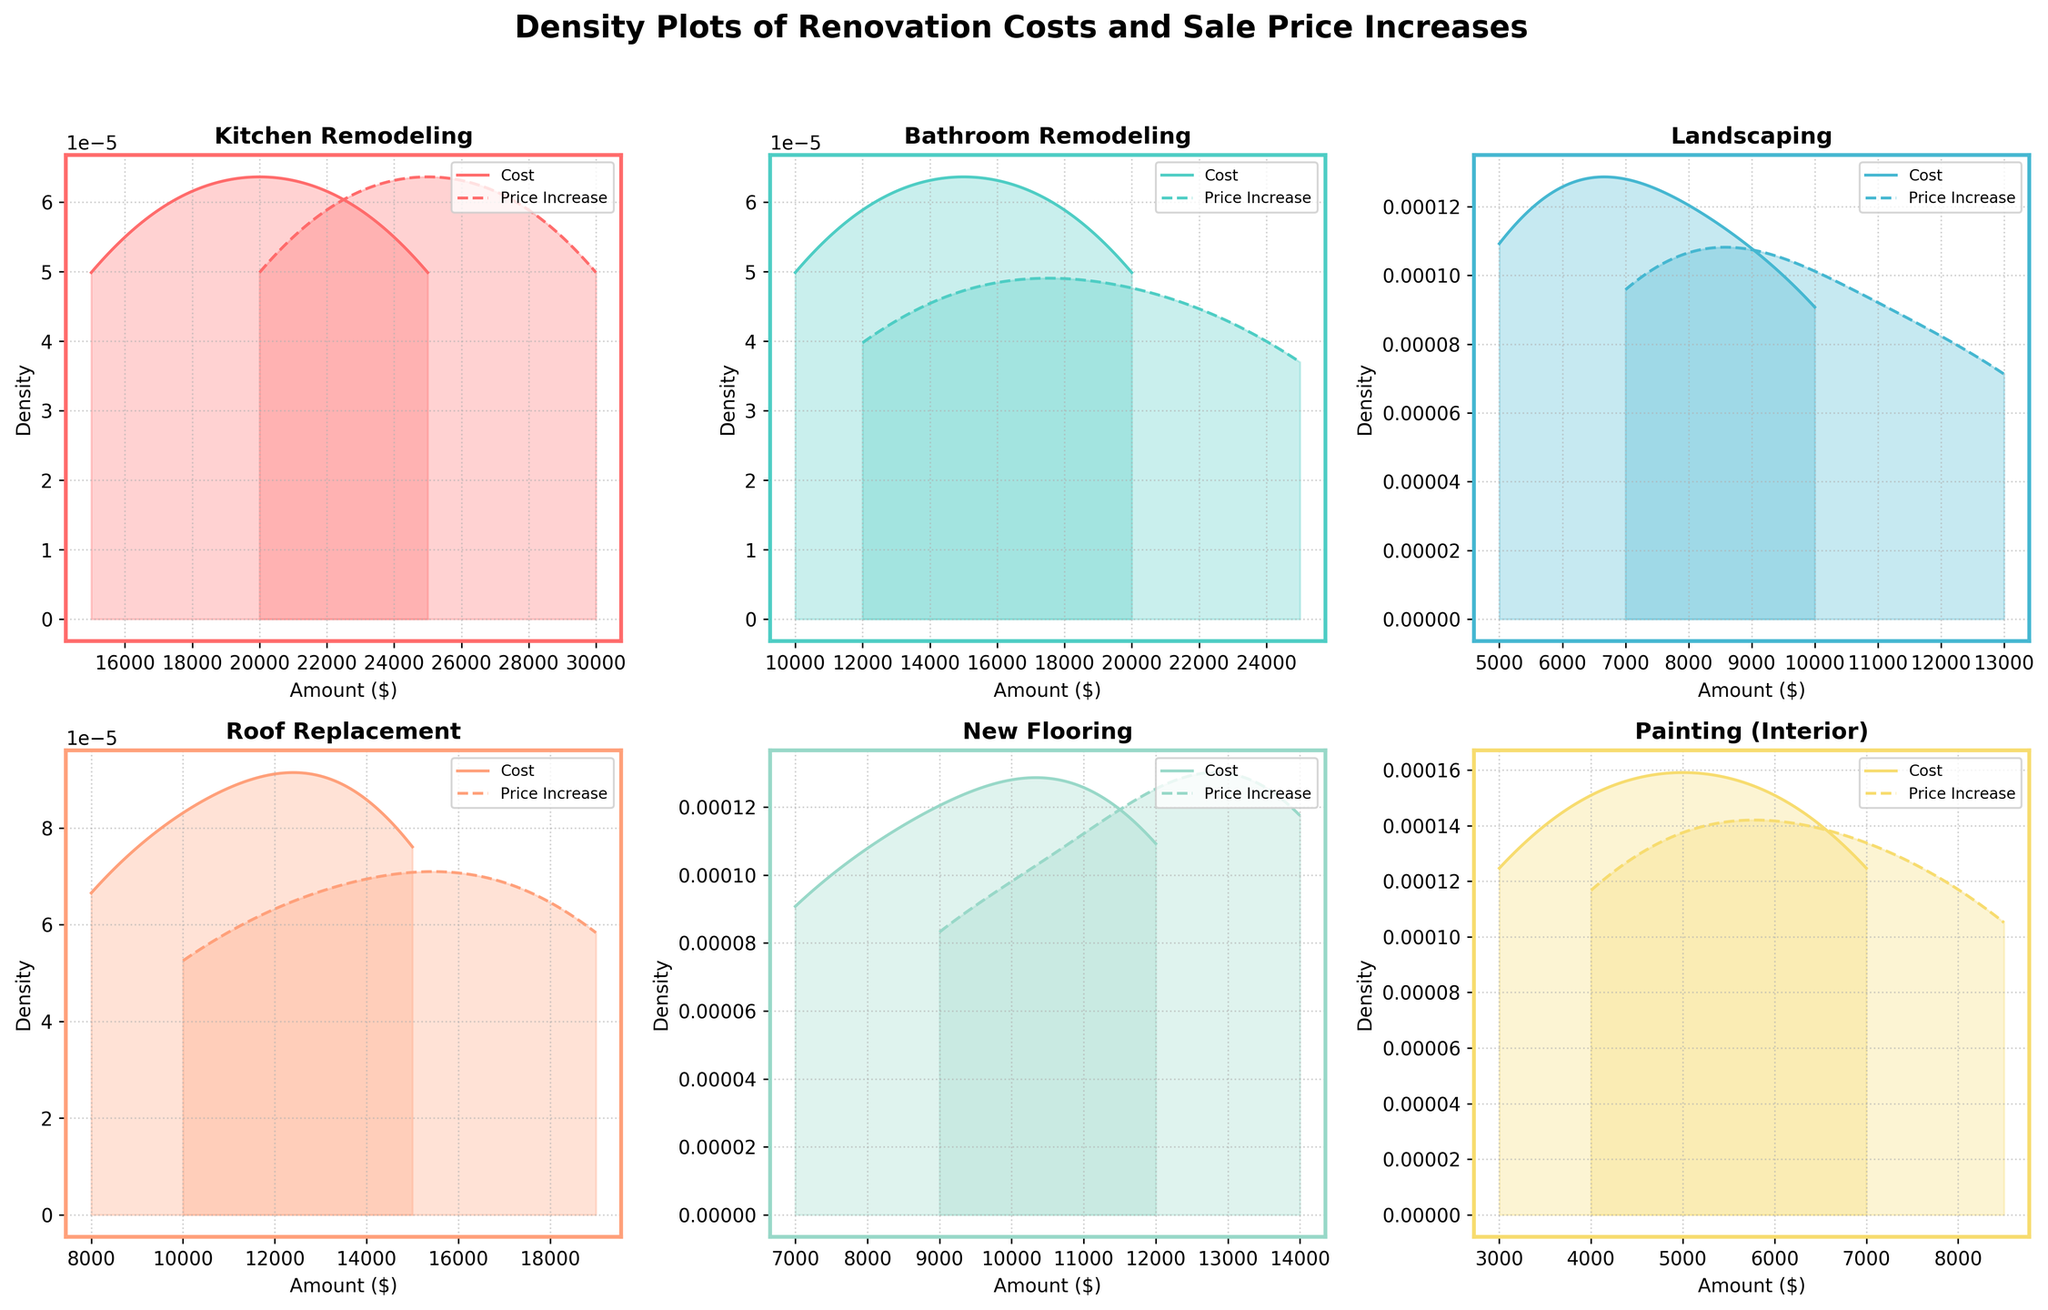how many renovation types are displayed in the plot? The figure has a separate density plot for each type of renovation, and the titles of each subplot show the renovation types. By counting the number of subplots, we can determine the number of renovation types. There are 6 types in total.
Answer: 6 what does the solid line represent in each subplot? Each subplot contains two lines, a solid and a dashed one. According to the labels in the legend, the solid line represents the estimated density of renovation costs.
Answer: Estimated density of renovation costs which renovation type has the highest density peak for cost? By comparing the peaks of the solid lines in each subplot, we see that 'Kitchen Remodeling' exhibits the highest peak in the estimated density for costs.
Answer: Kitchen Remodeling what is the x-axis label in each subplot? Each subplot has axes labeled, and the x-axis is titled 'Amount ($)', which represents the monetary value measured in dollars.
Answer: Amount ($) which renovation type has the smallest width of distribution for cost? Observing the width of the solid lines' spread along the x-axis in each subplot, 'Painting (Interior)' demonstrates the smallest width, indicating the smallest variation in renovation costs.
Answer: Painting (Interior) does roofing replacement display a higher peak density for cost or price increase? In the 'Roof Replacement' subplot, we compare the heights of the solid and dashed lines. The solid line (cost) shows a higher peak density than the dashed line (price increase).
Answer: Cost has higher peak density which renovation type has the highest density peak for price increase? By examining the peaks of the dashed lines in each subplot, 'Kitchen Remodeling' shows the highest density peak for the price increase, suggesting a significant increase in sale price.
Answer: Kitchen Remodeling are the densities for cost and price increase for new flooring closely aligned or spread apart? Looking at the 'New Flooring' subplot, the solid (cost) and dashed (price increase) lines are quite close to each other, indicating closely aligned densities.
Answer: Closely aligned which renovation type appears to be the most variable in terms of price increase? The variation can be assessed by looking at the spread of the dashed line in each subplot. 'Kitchen Remodeling' shows a wide spread in the dashed line, indicating high variability in price increase.
Answer: Kitchen Remodeling which renovation type shows a higher density peak for a lower amount in both cost and price increase? Looking at both solid and dashed lines across the subplots, 'Painting (Interior)' shows density peaks at lower amounts in both cost and price increase.
Answer: Painting (Interior) 